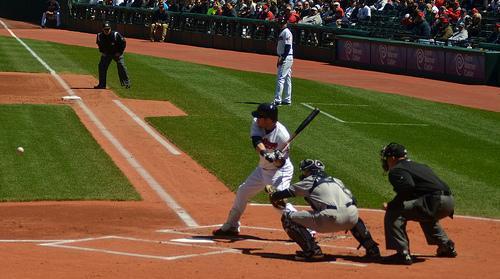How many people are on the field?
Give a very brief answer. 5. How many men are on the field?
Give a very brief answer. 5. How many players are shown?
Give a very brief answer. 3. 